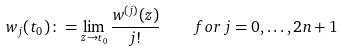<formula> <loc_0><loc_0><loc_500><loc_500>w _ { j } ( t _ { 0 } ) \colon = \lim _ { z \to t _ { 0 } } \frac { w ^ { ( j ) } ( z ) } { j ! } \quad f o r \, j = 0 , \dots , 2 n + 1</formula> 